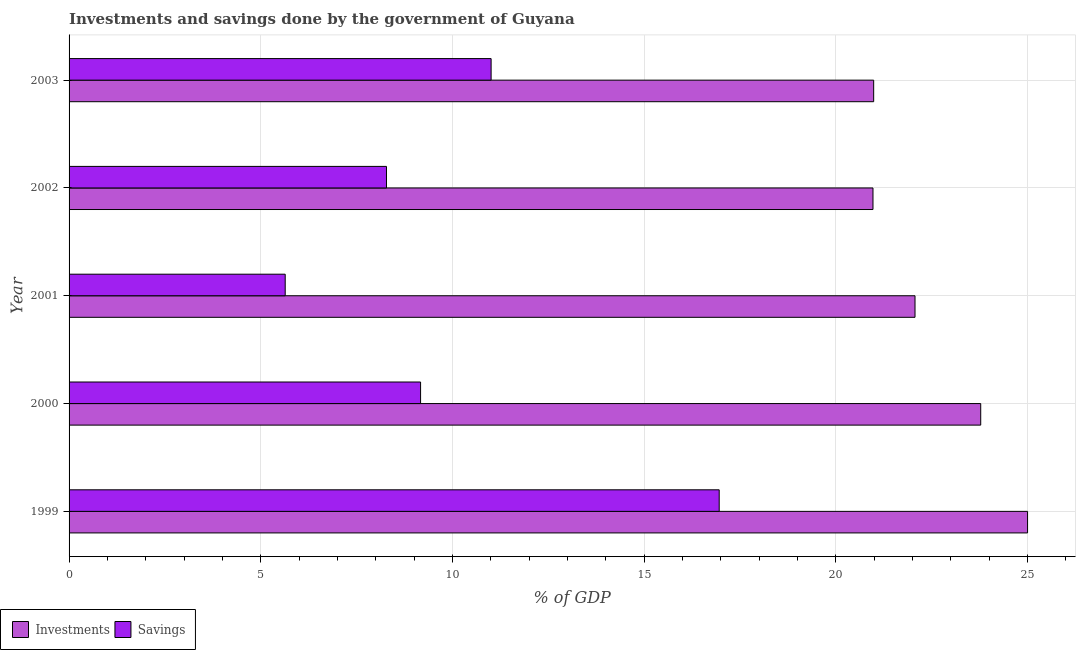Are the number of bars on each tick of the Y-axis equal?
Offer a terse response. Yes. How many bars are there on the 2nd tick from the top?
Your answer should be very brief. 2. In how many cases, is the number of bars for a given year not equal to the number of legend labels?
Give a very brief answer. 0. What is the investments of government in 2000?
Your answer should be very brief. 23.78. Across all years, what is the maximum investments of government?
Keep it short and to the point. 25. Across all years, what is the minimum savings of government?
Give a very brief answer. 5.64. In which year was the investments of government maximum?
Give a very brief answer. 1999. In which year was the savings of government minimum?
Give a very brief answer. 2001. What is the total savings of government in the graph?
Provide a short and direct response. 51.05. What is the difference between the investments of government in 2001 and that in 2003?
Your response must be concise. 1.08. What is the difference between the investments of government in 2000 and the savings of government in 2003?
Your response must be concise. 12.77. What is the average investments of government per year?
Keep it short and to the point. 22.56. In the year 2003, what is the difference between the savings of government and investments of government?
Offer a very short reply. -9.98. What is the ratio of the savings of government in 1999 to that in 2000?
Keep it short and to the point. 1.85. Is the investments of government in 1999 less than that in 2001?
Give a very brief answer. No. What is the difference between the highest and the second highest savings of government?
Give a very brief answer. 5.95. What is the difference between the highest and the lowest savings of government?
Offer a very short reply. 11.32. In how many years, is the savings of government greater than the average savings of government taken over all years?
Ensure brevity in your answer.  2. What does the 2nd bar from the top in 2001 represents?
Your answer should be very brief. Investments. What does the 1st bar from the bottom in 2000 represents?
Keep it short and to the point. Investments. Are all the bars in the graph horizontal?
Your answer should be very brief. Yes. What is the difference between two consecutive major ticks on the X-axis?
Make the answer very short. 5. Are the values on the major ticks of X-axis written in scientific E-notation?
Your response must be concise. No. Does the graph contain any zero values?
Give a very brief answer. No. Does the graph contain grids?
Your response must be concise. Yes. Where does the legend appear in the graph?
Your answer should be very brief. Bottom left. How many legend labels are there?
Make the answer very short. 2. What is the title of the graph?
Offer a terse response. Investments and savings done by the government of Guyana. What is the label or title of the X-axis?
Give a very brief answer. % of GDP. What is the label or title of the Y-axis?
Provide a short and direct response. Year. What is the % of GDP of Investments in 1999?
Your response must be concise. 25. What is the % of GDP in Savings in 1999?
Provide a short and direct response. 16.96. What is the % of GDP of Investments in 2000?
Offer a terse response. 23.78. What is the % of GDP of Savings in 2000?
Make the answer very short. 9.17. What is the % of GDP of Investments in 2001?
Your response must be concise. 22.06. What is the % of GDP in Savings in 2001?
Your answer should be compact. 5.64. What is the % of GDP of Investments in 2002?
Provide a succinct answer. 20.97. What is the % of GDP in Savings in 2002?
Provide a succinct answer. 8.28. What is the % of GDP of Investments in 2003?
Ensure brevity in your answer.  20.98. What is the % of GDP in Savings in 2003?
Provide a succinct answer. 11.01. Across all years, what is the maximum % of GDP of Investments?
Ensure brevity in your answer.  25. Across all years, what is the maximum % of GDP of Savings?
Make the answer very short. 16.96. Across all years, what is the minimum % of GDP in Investments?
Ensure brevity in your answer.  20.97. Across all years, what is the minimum % of GDP of Savings?
Make the answer very short. 5.64. What is the total % of GDP in Investments in the graph?
Provide a short and direct response. 112.79. What is the total % of GDP in Savings in the graph?
Make the answer very short. 51.05. What is the difference between the % of GDP in Investments in 1999 and that in 2000?
Give a very brief answer. 1.22. What is the difference between the % of GDP of Savings in 1999 and that in 2000?
Give a very brief answer. 7.79. What is the difference between the % of GDP of Investments in 1999 and that in 2001?
Give a very brief answer. 2.94. What is the difference between the % of GDP of Savings in 1999 and that in 2001?
Ensure brevity in your answer.  11.32. What is the difference between the % of GDP of Investments in 1999 and that in 2002?
Keep it short and to the point. 4.03. What is the difference between the % of GDP in Savings in 1999 and that in 2002?
Ensure brevity in your answer.  8.68. What is the difference between the % of GDP in Investments in 1999 and that in 2003?
Make the answer very short. 4.01. What is the difference between the % of GDP in Savings in 1999 and that in 2003?
Your answer should be very brief. 5.95. What is the difference between the % of GDP in Investments in 2000 and that in 2001?
Your answer should be compact. 1.71. What is the difference between the % of GDP in Savings in 2000 and that in 2001?
Provide a succinct answer. 3.53. What is the difference between the % of GDP of Investments in 2000 and that in 2002?
Give a very brief answer. 2.81. What is the difference between the % of GDP in Savings in 2000 and that in 2002?
Your response must be concise. 0.89. What is the difference between the % of GDP of Investments in 2000 and that in 2003?
Your response must be concise. 2.79. What is the difference between the % of GDP of Savings in 2000 and that in 2003?
Make the answer very short. -1.84. What is the difference between the % of GDP in Investments in 2001 and that in 2002?
Keep it short and to the point. 1.1. What is the difference between the % of GDP of Savings in 2001 and that in 2002?
Keep it short and to the point. -2.64. What is the difference between the % of GDP of Investments in 2001 and that in 2003?
Offer a terse response. 1.08. What is the difference between the % of GDP of Savings in 2001 and that in 2003?
Give a very brief answer. -5.37. What is the difference between the % of GDP of Investments in 2002 and that in 2003?
Make the answer very short. -0.02. What is the difference between the % of GDP of Savings in 2002 and that in 2003?
Offer a terse response. -2.73. What is the difference between the % of GDP of Investments in 1999 and the % of GDP of Savings in 2000?
Offer a terse response. 15.83. What is the difference between the % of GDP of Investments in 1999 and the % of GDP of Savings in 2001?
Ensure brevity in your answer.  19.36. What is the difference between the % of GDP in Investments in 1999 and the % of GDP in Savings in 2002?
Your response must be concise. 16.72. What is the difference between the % of GDP in Investments in 1999 and the % of GDP in Savings in 2003?
Give a very brief answer. 13.99. What is the difference between the % of GDP in Investments in 2000 and the % of GDP in Savings in 2001?
Your answer should be very brief. 18.14. What is the difference between the % of GDP in Investments in 2000 and the % of GDP in Savings in 2002?
Your response must be concise. 15.5. What is the difference between the % of GDP of Investments in 2000 and the % of GDP of Savings in 2003?
Provide a short and direct response. 12.77. What is the difference between the % of GDP in Investments in 2001 and the % of GDP in Savings in 2002?
Provide a short and direct response. 13.78. What is the difference between the % of GDP in Investments in 2001 and the % of GDP in Savings in 2003?
Provide a succinct answer. 11.06. What is the difference between the % of GDP in Investments in 2002 and the % of GDP in Savings in 2003?
Offer a very short reply. 9.96. What is the average % of GDP of Investments per year?
Offer a terse response. 22.56. What is the average % of GDP of Savings per year?
Provide a short and direct response. 10.21. In the year 1999, what is the difference between the % of GDP in Investments and % of GDP in Savings?
Ensure brevity in your answer.  8.04. In the year 2000, what is the difference between the % of GDP in Investments and % of GDP in Savings?
Provide a succinct answer. 14.61. In the year 2001, what is the difference between the % of GDP in Investments and % of GDP in Savings?
Your response must be concise. 16.43. In the year 2002, what is the difference between the % of GDP of Investments and % of GDP of Savings?
Provide a succinct answer. 12.69. In the year 2003, what is the difference between the % of GDP of Investments and % of GDP of Savings?
Make the answer very short. 9.98. What is the ratio of the % of GDP of Investments in 1999 to that in 2000?
Offer a terse response. 1.05. What is the ratio of the % of GDP in Savings in 1999 to that in 2000?
Make the answer very short. 1.85. What is the ratio of the % of GDP of Investments in 1999 to that in 2001?
Offer a very short reply. 1.13. What is the ratio of the % of GDP of Savings in 1999 to that in 2001?
Make the answer very short. 3.01. What is the ratio of the % of GDP of Investments in 1999 to that in 2002?
Ensure brevity in your answer.  1.19. What is the ratio of the % of GDP of Savings in 1999 to that in 2002?
Your answer should be compact. 2.05. What is the ratio of the % of GDP of Investments in 1999 to that in 2003?
Your response must be concise. 1.19. What is the ratio of the % of GDP of Savings in 1999 to that in 2003?
Provide a short and direct response. 1.54. What is the ratio of the % of GDP of Investments in 2000 to that in 2001?
Keep it short and to the point. 1.08. What is the ratio of the % of GDP in Savings in 2000 to that in 2001?
Ensure brevity in your answer.  1.63. What is the ratio of the % of GDP in Investments in 2000 to that in 2002?
Provide a succinct answer. 1.13. What is the ratio of the % of GDP of Savings in 2000 to that in 2002?
Your response must be concise. 1.11. What is the ratio of the % of GDP of Investments in 2000 to that in 2003?
Provide a short and direct response. 1.13. What is the ratio of the % of GDP in Savings in 2000 to that in 2003?
Provide a short and direct response. 0.83. What is the ratio of the % of GDP in Investments in 2001 to that in 2002?
Your answer should be compact. 1.05. What is the ratio of the % of GDP in Savings in 2001 to that in 2002?
Your response must be concise. 0.68. What is the ratio of the % of GDP of Investments in 2001 to that in 2003?
Make the answer very short. 1.05. What is the ratio of the % of GDP in Savings in 2001 to that in 2003?
Make the answer very short. 0.51. What is the ratio of the % of GDP in Investments in 2002 to that in 2003?
Ensure brevity in your answer.  1. What is the ratio of the % of GDP in Savings in 2002 to that in 2003?
Your response must be concise. 0.75. What is the difference between the highest and the second highest % of GDP in Investments?
Provide a short and direct response. 1.22. What is the difference between the highest and the second highest % of GDP of Savings?
Make the answer very short. 5.95. What is the difference between the highest and the lowest % of GDP in Investments?
Your answer should be very brief. 4.03. What is the difference between the highest and the lowest % of GDP of Savings?
Provide a succinct answer. 11.32. 